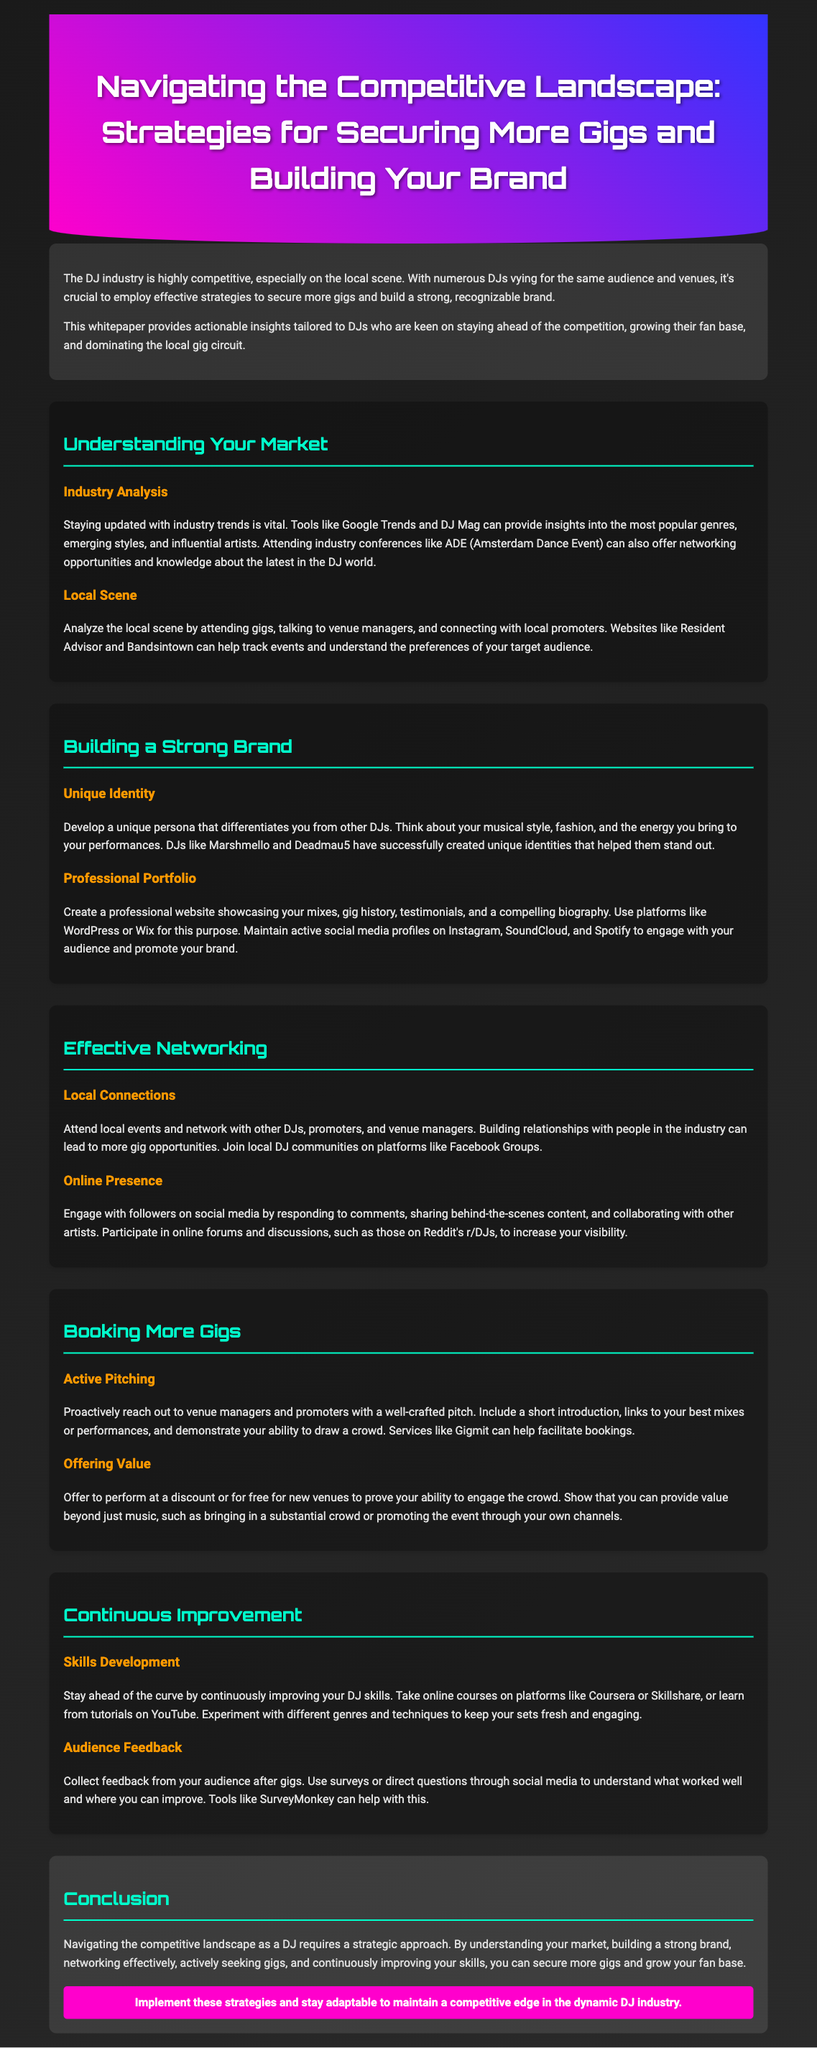What is the main purpose of the whitepaper? The purpose is to provide actionable insights for DJs to secure more gigs and build a strong brand.
Answer: actionable insights What industry event is mentioned as a networking opportunity? The document mentions ADE (Amsterdam Dance Event) as an industry conference.
Answer: ADE What should a DJ develop to differentiate themselves? DJs should develop a unique persona that reflects their musical style, fashion, and energy.
Answer: unique persona What online platforms are suggested for building a professional portfolio? The document suggests using WordPress or Wix to create a professional website.
Answer: WordPress or Wix Which tool is recommended for collecting audience feedback? SurveyMonkey is mentioned as a tool to help collect feedback from the audience.
Answer: SurveyMonkey What type of connections should DJs focus on for more gigs? DJs should focus on building local connections with other DJs, promoters, and venue managers.
Answer: local connections What is a suggested strategy for booking more gigs? Proactively reaching out to venue managers and promoters with a well-crafted pitch is advised.
Answer: active pitching How can DJs continuously improve their skills? DJs are encouraged to take online courses and learn from tutorials on platforms like Coursera or Skillshare.
Answer: online courses What is one way DJs can provide value to new venues? DJs can offer to perform at a discount or for free to demonstrate their ability to engage the crowd.
Answer: perform at a discount 